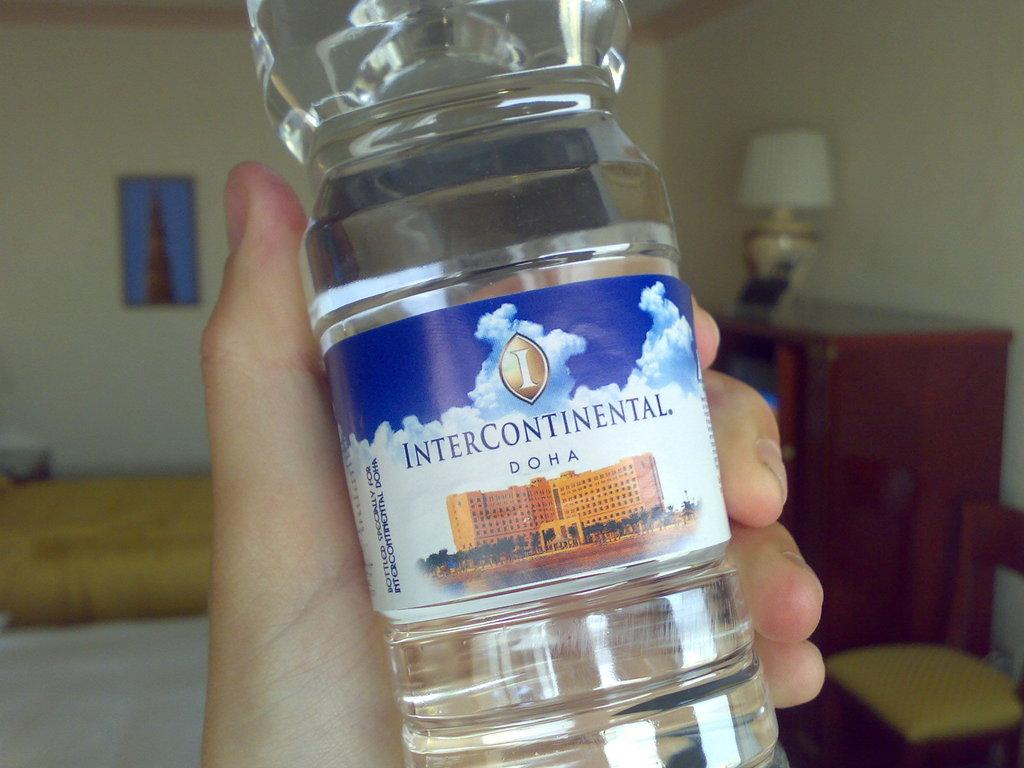Who is present in the image? There is a person in the image. What is the person holding in the image? The person is holding a bottle. What is the label on the bottle? The bottle is labeled as "intercontinental." What can be seen on the wall in the image? There is a frame on the wall in the image. What is on the table in the image? There is a lamp on a table in the image. What song is the person singing in the image? There is no indication in the image that the person is singing a song. 